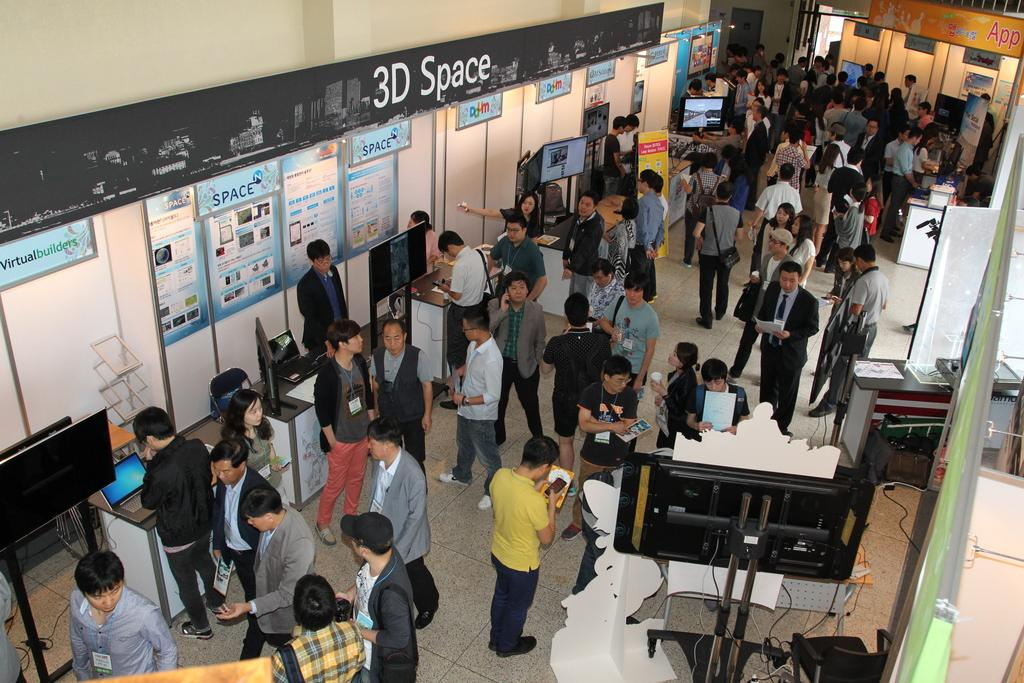What are the people in the image doing? The people in the image are standing on the floor. What electronic devices can be seen in the image? There are two laptops in the middle of the image. What type of signage is present in the image? There are banners in the image. What color is the wall in the image? The wall in the image is white in color. Can you see any water or coal in the image? No, there is no water or coal present in the image. 